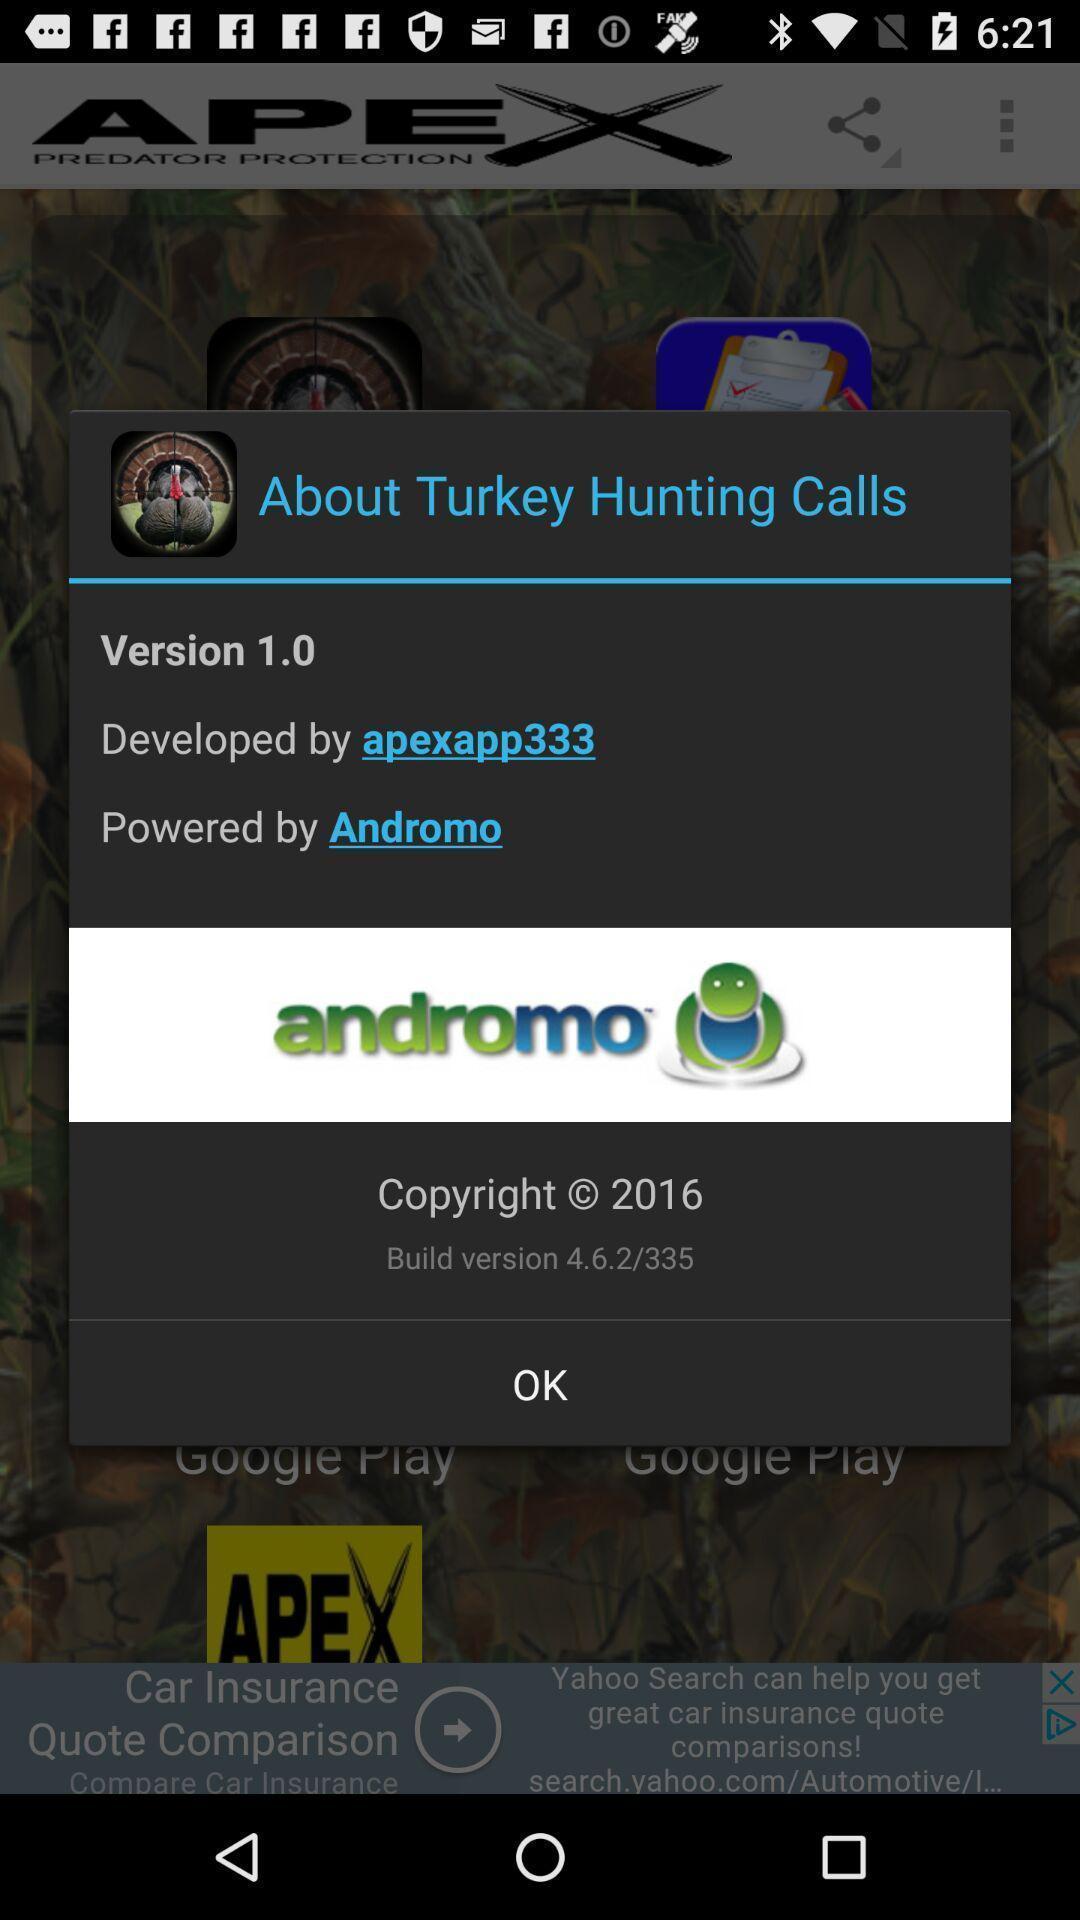Give me a narrative description of this picture. Pop-up showing information like version. 